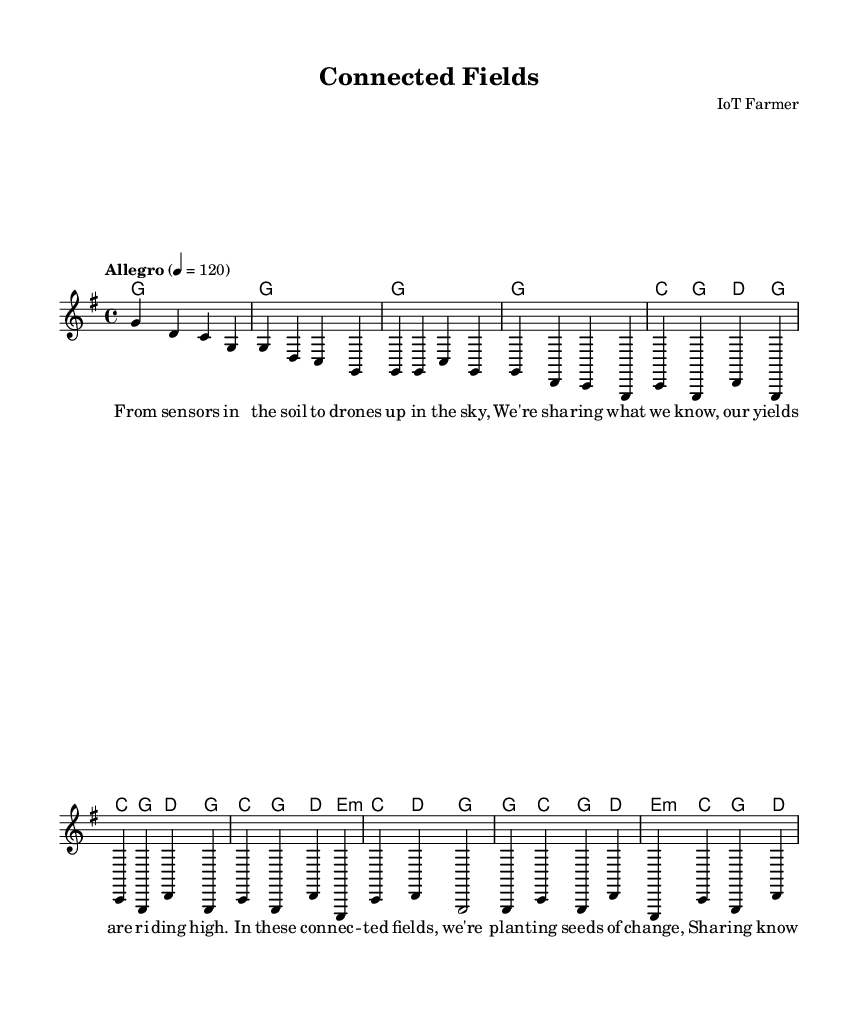What is the key signature of this music? The key signature indicated is G major, which has one sharp (F#). This can be identified by looking at the signature at the beginning of the staff.
Answer: G major What is the time signature of this piece? The time signature is 4/4, which is shown at the beginning of the score. This means there are four beats in each measure and a quarter note receives one beat.
Answer: 4/4 What is the tempo marking of the piece? The tempo marking is "Allegro," which suggests a fast and lively pace. This is specified at the start of the music.
Answer: Allegro How many measures are in the chorus? The chorus consists of four measures, as counted by looking at the section marked with the lyrics and the corresponding melodies.
Answer: Four What is the first lyric line in the verse? The first lyric line in the verse is "From sensors in the soil to drones up in the sky." This can be found defined in the lyrics section of the sheet music.
Answer: From sensors in the soil to drones up in the sky What type of chord is played during the chorus line "Sharing knowledge far and wide"? The chord progression during that lyric includes a C major chord, shown in the harmonies section. This chord appears in the context of the chorus, which includes both the melody and harmonic support.
Answer: C major What is the character of the song based on its structure and lyrics? The song character can be described as "Romantic" or "connected" which includes themes of community and sharing knowledge, as evident from both the lyrics and the overall context of the piece.
Answer: Romantic 